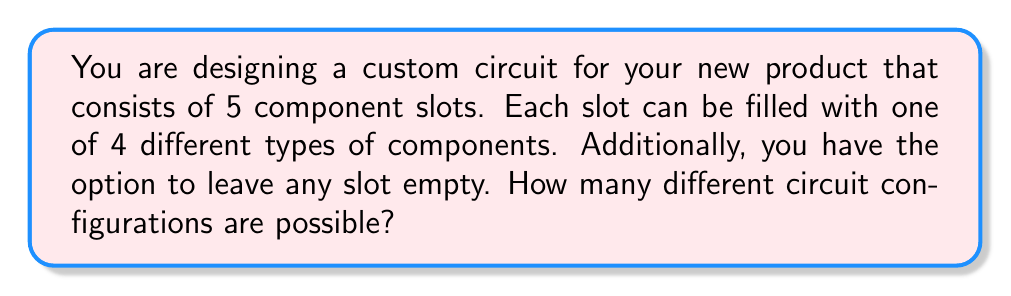Provide a solution to this math problem. Let's approach this problem step-by-step using combinatorial analysis:

1) For each slot, we have 5 options:
   - 4 different types of components
   - 1 option to leave it empty

2) This scenario is a perfect example of the multiplication principle in combinatorics. Since we have 5 independent choices (one for each slot), and each choice has 5 options, the total number of configurations is:

   $$ 5 \times 5 \times 5 \times 5 \times 5 = 5^5 $$

3) We can also express this using exponentiation:
   
   $$ \text{Number of configurations} = (\text{options per slot})^{\text{number of slots}} = 5^5 $$

4) To calculate $5^5$:

   $$ 5^5 = 5 \times 5 \times 5 \times 5 \times 5 = 3125 $$

Therefore, there are 3125 possible circuit configurations.
Answer: 3125 possible circuit configurations 